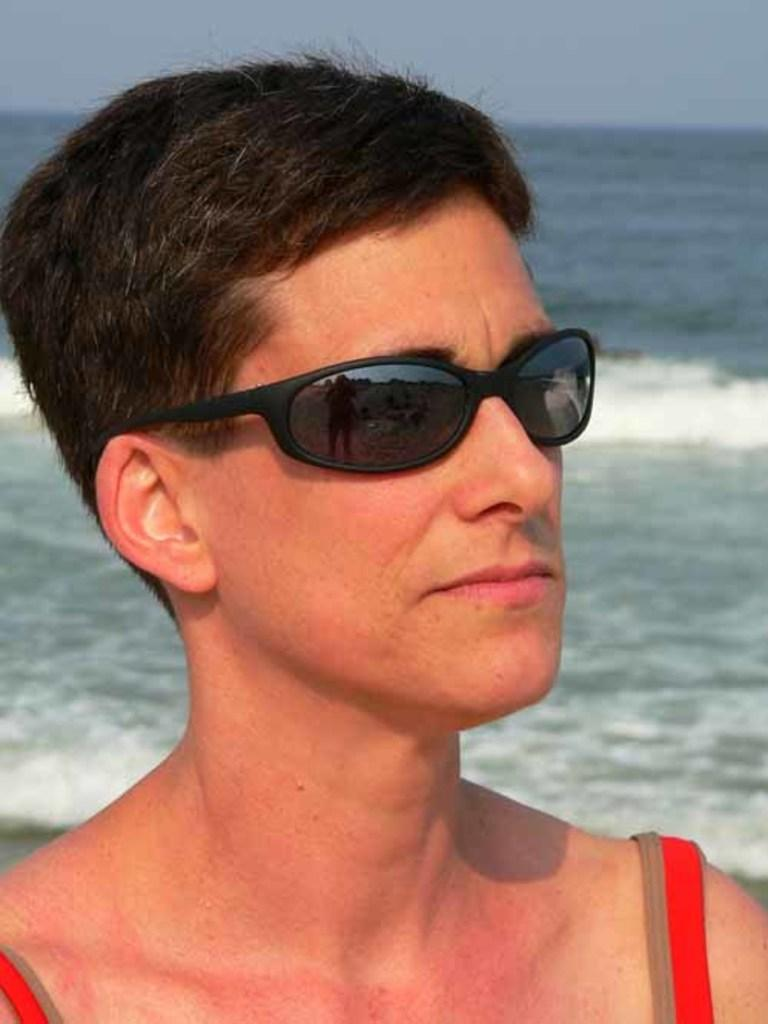Who or what is the main subject of the image? There is a person in the center of the image. What is the person wearing that is visible in the image? The person is wearing sunglasses. What can be seen in the background of the image? There is sky and water visible in the background of the image. What type of verse is being recited by the band in the image? There is no band present in the image, so it is not possible to determine if any verses are being recited. 